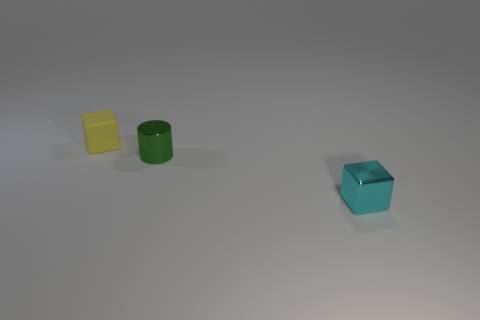How many matte blocks are the same size as the yellow matte thing?
Offer a terse response. 0. The shiny block has what color?
Offer a very short reply. Cyan. There is a matte thing; is it the same color as the shiny object left of the small cyan shiny block?
Your answer should be very brief. No. There is a cyan thing that is the same material as the tiny green cylinder; what is its size?
Your response must be concise. Small. Are there any small shiny balls that have the same color as the matte object?
Give a very brief answer. No. What number of objects are either small objects that are in front of the tiny yellow object or big green rubber balls?
Offer a very short reply. 2. Are the green thing and the tiny cube left of the small cyan shiny cube made of the same material?
Offer a terse response. No. Is there a large gray ball that has the same material as the tiny yellow object?
Your answer should be very brief. No. What number of things are blocks in front of the small yellow matte cube or tiny metal objects that are right of the cylinder?
Your answer should be compact. 1. There is a yellow thing; is its shape the same as the shiny object on the right side of the green thing?
Provide a short and direct response. Yes. 